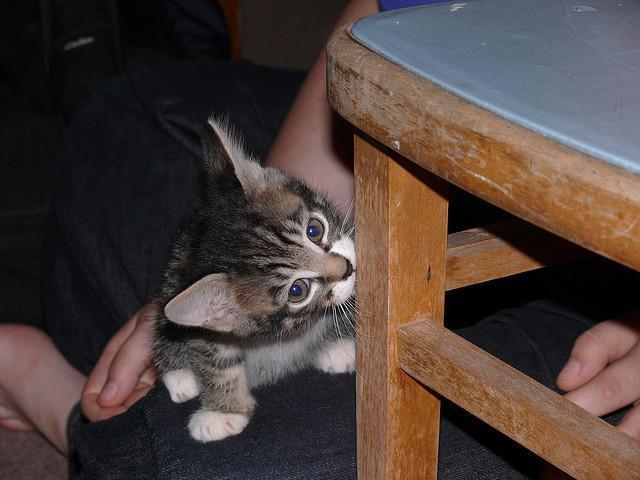How many cats are visible?
Give a very brief answer. 1. 